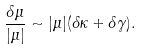<formula> <loc_0><loc_0><loc_500><loc_500>\frac { \delta \mu } { | \mu | } \sim | \mu | ( \delta \kappa + \delta \gamma ) .</formula> 